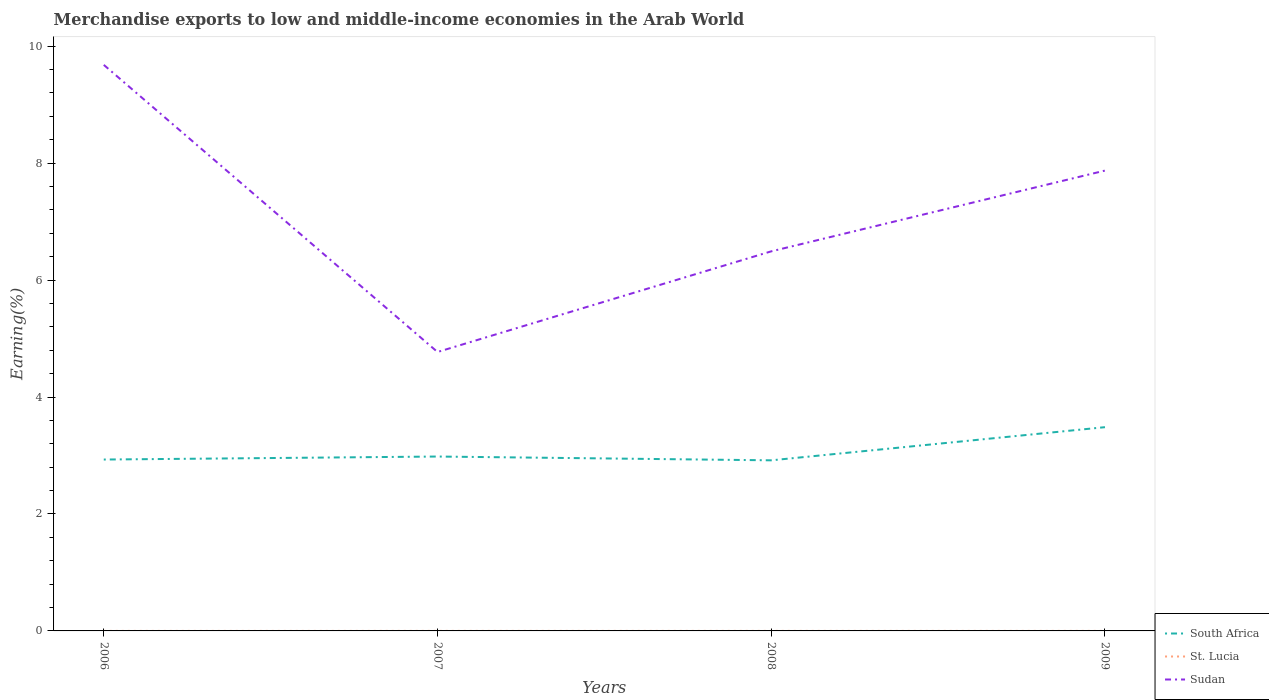Is the number of lines equal to the number of legend labels?
Make the answer very short. Yes. Across all years, what is the maximum percentage of amount earned from merchandise exports in Sudan?
Offer a terse response. 4.77. What is the total percentage of amount earned from merchandise exports in South Africa in the graph?
Your response must be concise. -0.55. What is the difference between the highest and the second highest percentage of amount earned from merchandise exports in Sudan?
Your answer should be compact. 4.91. Is the percentage of amount earned from merchandise exports in St. Lucia strictly greater than the percentage of amount earned from merchandise exports in South Africa over the years?
Provide a short and direct response. Yes. How many lines are there?
Your response must be concise. 3. How many years are there in the graph?
Provide a short and direct response. 4. Does the graph contain grids?
Offer a terse response. No. Where does the legend appear in the graph?
Keep it short and to the point. Bottom right. How are the legend labels stacked?
Make the answer very short. Vertical. What is the title of the graph?
Your response must be concise. Merchandise exports to low and middle-income economies in the Arab World. Does "Barbados" appear as one of the legend labels in the graph?
Ensure brevity in your answer.  No. What is the label or title of the X-axis?
Keep it short and to the point. Years. What is the label or title of the Y-axis?
Offer a very short reply. Earning(%). What is the Earning(%) of South Africa in 2006?
Make the answer very short. 2.93. What is the Earning(%) of St. Lucia in 2006?
Give a very brief answer. 0. What is the Earning(%) in Sudan in 2006?
Give a very brief answer. 9.68. What is the Earning(%) of South Africa in 2007?
Make the answer very short. 2.98. What is the Earning(%) in St. Lucia in 2007?
Your response must be concise. 0. What is the Earning(%) in Sudan in 2007?
Provide a short and direct response. 4.77. What is the Earning(%) in South Africa in 2008?
Keep it short and to the point. 2.92. What is the Earning(%) of St. Lucia in 2008?
Keep it short and to the point. 0. What is the Earning(%) of Sudan in 2008?
Offer a terse response. 6.49. What is the Earning(%) in South Africa in 2009?
Offer a terse response. 3.48. What is the Earning(%) of St. Lucia in 2009?
Give a very brief answer. 0. What is the Earning(%) of Sudan in 2009?
Provide a succinct answer. 7.87. Across all years, what is the maximum Earning(%) in South Africa?
Your answer should be compact. 3.48. Across all years, what is the maximum Earning(%) in St. Lucia?
Provide a short and direct response. 0. Across all years, what is the maximum Earning(%) in Sudan?
Offer a very short reply. 9.68. Across all years, what is the minimum Earning(%) of South Africa?
Provide a short and direct response. 2.92. Across all years, what is the minimum Earning(%) of St. Lucia?
Your answer should be compact. 0. Across all years, what is the minimum Earning(%) of Sudan?
Your answer should be compact. 4.77. What is the total Earning(%) in South Africa in the graph?
Your answer should be very brief. 12.31. What is the total Earning(%) in St. Lucia in the graph?
Ensure brevity in your answer.  0. What is the total Earning(%) in Sudan in the graph?
Your response must be concise. 28.81. What is the difference between the Earning(%) of South Africa in 2006 and that in 2007?
Ensure brevity in your answer.  -0.05. What is the difference between the Earning(%) in St. Lucia in 2006 and that in 2007?
Make the answer very short. -0. What is the difference between the Earning(%) in Sudan in 2006 and that in 2007?
Make the answer very short. 4.91. What is the difference between the Earning(%) of South Africa in 2006 and that in 2008?
Give a very brief answer. 0.01. What is the difference between the Earning(%) in St. Lucia in 2006 and that in 2008?
Your answer should be compact. -0. What is the difference between the Earning(%) in Sudan in 2006 and that in 2008?
Provide a succinct answer. 3.19. What is the difference between the Earning(%) of South Africa in 2006 and that in 2009?
Offer a very short reply. -0.55. What is the difference between the Earning(%) of St. Lucia in 2006 and that in 2009?
Give a very brief answer. -0. What is the difference between the Earning(%) in Sudan in 2006 and that in 2009?
Provide a short and direct response. 1.81. What is the difference between the Earning(%) in South Africa in 2007 and that in 2008?
Your response must be concise. 0.06. What is the difference between the Earning(%) in St. Lucia in 2007 and that in 2008?
Your answer should be very brief. -0. What is the difference between the Earning(%) of Sudan in 2007 and that in 2008?
Offer a very short reply. -1.72. What is the difference between the Earning(%) in South Africa in 2007 and that in 2009?
Ensure brevity in your answer.  -0.5. What is the difference between the Earning(%) in Sudan in 2007 and that in 2009?
Your answer should be compact. -3.1. What is the difference between the Earning(%) of South Africa in 2008 and that in 2009?
Offer a very short reply. -0.57. What is the difference between the Earning(%) of Sudan in 2008 and that in 2009?
Your answer should be very brief. -1.38. What is the difference between the Earning(%) of South Africa in 2006 and the Earning(%) of St. Lucia in 2007?
Provide a succinct answer. 2.93. What is the difference between the Earning(%) of South Africa in 2006 and the Earning(%) of Sudan in 2007?
Give a very brief answer. -1.84. What is the difference between the Earning(%) of St. Lucia in 2006 and the Earning(%) of Sudan in 2007?
Your answer should be very brief. -4.77. What is the difference between the Earning(%) of South Africa in 2006 and the Earning(%) of St. Lucia in 2008?
Your answer should be very brief. 2.93. What is the difference between the Earning(%) in South Africa in 2006 and the Earning(%) in Sudan in 2008?
Your answer should be compact. -3.56. What is the difference between the Earning(%) of St. Lucia in 2006 and the Earning(%) of Sudan in 2008?
Offer a terse response. -6.49. What is the difference between the Earning(%) of South Africa in 2006 and the Earning(%) of St. Lucia in 2009?
Keep it short and to the point. 2.93. What is the difference between the Earning(%) of South Africa in 2006 and the Earning(%) of Sudan in 2009?
Provide a succinct answer. -4.94. What is the difference between the Earning(%) of St. Lucia in 2006 and the Earning(%) of Sudan in 2009?
Keep it short and to the point. -7.87. What is the difference between the Earning(%) of South Africa in 2007 and the Earning(%) of St. Lucia in 2008?
Ensure brevity in your answer.  2.98. What is the difference between the Earning(%) in South Africa in 2007 and the Earning(%) in Sudan in 2008?
Offer a terse response. -3.51. What is the difference between the Earning(%) in St. Lucia in 2007 and the Earning(%) in Sudan in 2008?
Ensure brevity in your answer.  -6.49. What is the difference between the Earning(%) of South Africa in 2007 and the Earning(%) of St. Lucia in 2009?
Your response must be concise. 2.98. What is the difference between the Earning(%) in South Africa in 2007 and the Earning(%) in Sudan in 2009?
Your answer should be very brief. -4.89. What is the difference between the Earning(%) in St. Lucia in 2007 and the Earning(%) in Sudan in 2009?
Offer a very short reply. -7.87. What is the difference between the Earning(%) of South Africa in 2008 and the Earning(%) of St. Lucia in 2009?
Your answer should be compact. 2.92. What is the difference between the Earning(%) in South Africa in 2008 and the Earning(%) in Sudan in 2009?
Make the answer very short. -4.95. What is the difference between the Earning(%) in St. Lucia in 2008 and the Earning(%) in Sudan in 2009?
Your answer should be compact. -7.87. What is the average Earning(%) in South Africa per year?
Provide a short and direct response. 3.08. What is the average Earning(%) of St. Lucia per year?
Offer a very short reply. 0. What is the average Earning(%) in Sudan per year?
Your answer should be compact. 7.2. In the year 2006, what is the difference between the Earning(%) in South Africa and Earning(%) in St. Lucia?
Give a very brief answer. 2.93. In the year 2006, what is the difference between the Earning(%) of South Africa and Earning(%) of Sudan?
Make the answer very short. -6.75. In the year 2006, what is the difference between the Earning(%) in St. Lucia and Earning(%) in Sudan?
Make the answer very short. -9.68. In the year 2007, what is the difference between the Earning(%) of South Africa and Earning(%) of St. Lucia?
Your answer should be compact. 2.98. In the year 2007, what is the difference between the Earning(%) of South Africa and Earning(%) of Sudan?
Offer a very short reply. -1.79. In the year 2007, what is the difference between the Earning(%) in St. Lucia and Earning(%) in Sudan?
Offer a very short reply. -4.77. In the year 2008, what is the difference between the Earning(%) in South Africa and Earning(%) in St. Lucia?
Your answer should be compact. 2.92. In the year 2008, what is the difference between the Earning(%) of South Africa and Earning(%) of Sudan?
Give a very brief answer. -3.57. In the year 2008, what is the difference between the Earning(%) in St. Lucia and Earning(%) in Sudan?
Provide a succinct answer. -6.49. In the year 2009, what is the difference between the Earning(%) in South Africa and Earning(%) in St. Lucia?
Your answer should be very brief. 3.48. In the year 2009, what is the difference between the Earning(%) in South Africa and Earning(%) in Sudan?
Ensure brevity in your answer.  -4.39. In the year 2009, what is the difference between the Earning(%) in St. Lucia and Earning(%) in Sudan?
Offer a terse response. -7.87. What is the ratio of the Earning(%) of South Africa in 2006 to that in 2007?
Provide a succinct answer. 0.98. What is the ratio of the Earning(%) of St. Lucia in 2006 to that in 2007?
Your response must be concise. 0.35. What is the ratio of the Earning(%) in Sudan in 2006 to that in 2007?
Give a very brief answer. 2.03. What is the ratio of the Earning(%) in St. Lucia in 2006 to that in 2008?
Offer a very short reply. 0.26. What is the ratio of the Earning(%) of Sudan in 2006 to that in 2008?
Offer a terse response. 1.49. What is the ratio of the Earning(%) in South Africa in 2006 to that in 2009?
Your response must be concise. 0.84. What is the ratio of the Earning(%) of St. Lucia in 2006 to that in 2009?
Make the answer very short. 0.41. What is the ratio of the Earning(%) of Sudan in 2006 to that in 2009?
Make the answer very short. 1.23. What is the ratio of the Earning(%) in South Africa in 2007 to that in 2008?
Offer a very short reply. 1.02. What is the ratio of the Earning(%) of St. Lucia in 2007 to that in 2008?
Keep it short and to the point. 0.75. What is the ratio of the Earning(%) in Sudan in 2007 to that in 2008?
Offer a terse response. 0.73. What is the ratio of the Earning(%) of South Africa in 2007 to that in 2009?
Your response must be concise. 0.86. What is the ratio of the Earning(%) in St. Lucia in 2007 to that in 2009?
Keep it short and to the point. 1.16. What is the ratio of the Earning(%) of Sudan in 2007 to that in 2009?
Your response must be concise. 0.61. What is the ratio of the Earning(%) of South Africa in 2008 to that in 2009?
Make the answer very short. 0.84. What is the ratio of the Earning(%) in St. Lucia in 2008 to that in 2009?
Make the answer very short. 1.55. What is the ratio of the Earning(%) of Sudan in 2008 to that in 2009?
Provide a short and direct response. 0.82. What is the difference between the highest and the second highest Earning(%) in South Africa?
Give a very brief answer. 0.5. What is the difference between the highest and the second highest Earning(%) of St. Lucia?
Provide a succinct answer. 0. What is the difference between the highest and the second highest Earning(%) in Sudan?
Provide a succinct answer. 1.81. What is the difference between the highest and the lowest Earning(%) of South Africa?
Your answer should be very brief. 0.57. What is the difference between the highest and the lowest Earning(%) of Sudan?
Provide a succinct answer. 4.91. 